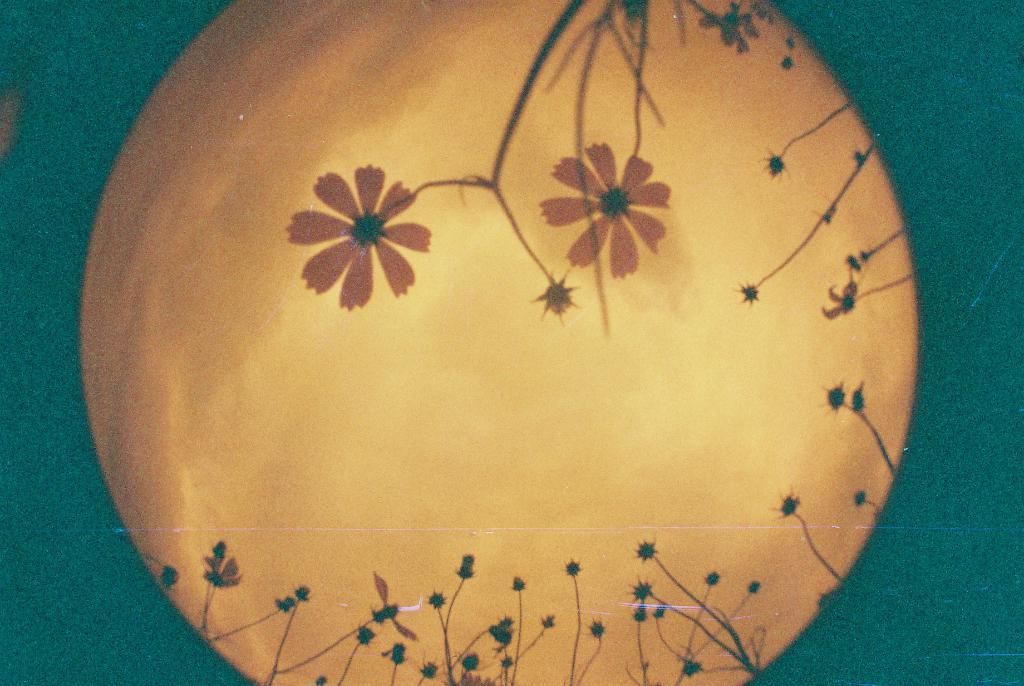What is the main subject of the image? The image contains a painting. What is depicted in the painting? The painting features flowers and plants. What color is the background of the painting? The background of the painting is green. What type of loss is depicted in the painting? There is no loss depicted in the painting; it features flowers and plants in a green background. Can you tell me how many pockets are visible in the painting? There are no pockets present in the painting, as it is a painting of flowers and plants. 